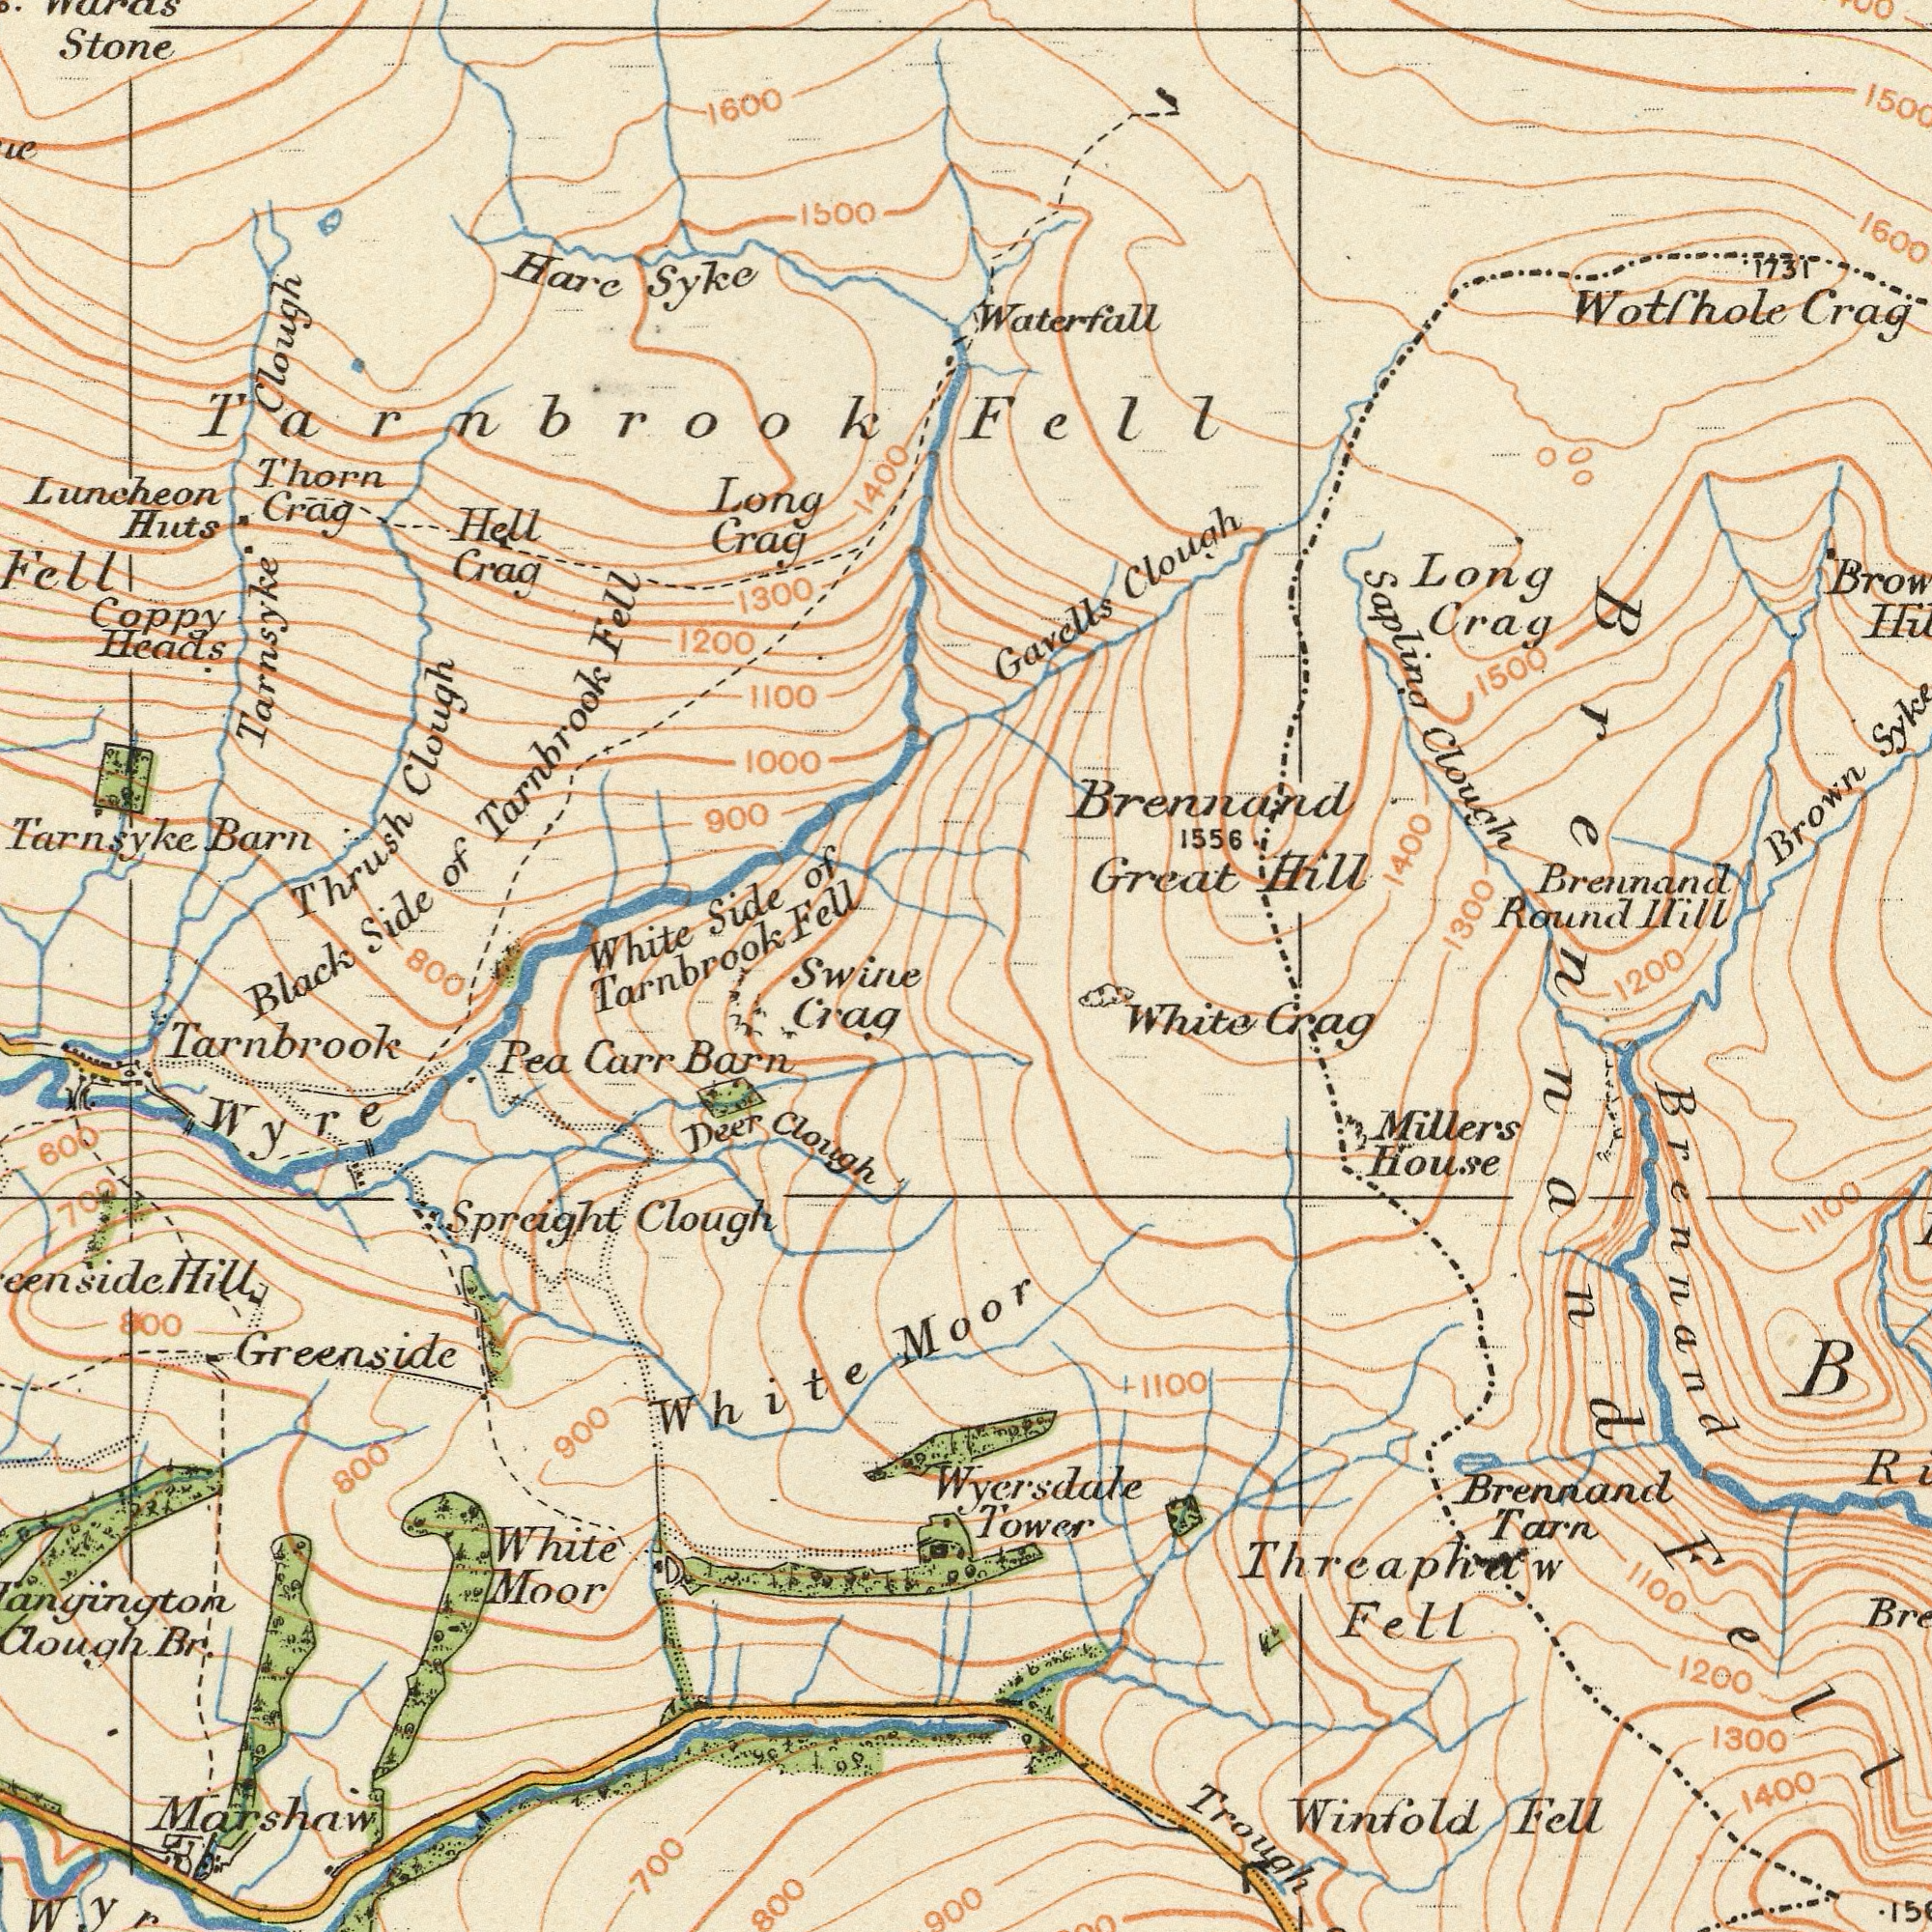What text can you see in the top-right section? Great Round Clough Brennand Long Crag Clough Hill 1600 1556 Crag Brown Hill Gavells 1731 Sapling Brennand Fell Waterfall Wotfhole 1500 1400 1300 1200 What text is shown in the bottom-left quadrant? Carr Barn Spreight Clough Deer Clough Greenside White Pea Marshaw Br. 700 800 600 Tarnbrook Moor Wyre 900 702 800 Hill Crag White 800 900 What text appears in the bottom-right area of the image? Brennand Trough Winfold Millers White Crag House Fell 1100 1200 Fell 1400 Tarn 1100 Brennand Threaphaw 1100 1300 Moor Wyersdale Tower Brennand Fell What text is shown in the top-left quadrant? Stone Hare Coppy Heads Long Thorn Huts 1500 Crag Fell Clough 1000 Hell Crag 1300 1200 900 Side Syke 1600 1100 Thrush Crag 1400 Tarnbrook of Tarnsyke Barn Tarnsyke Luncheon Tarnbrook Clough Black White Side Of Tarnbrook Fell Swine 800 